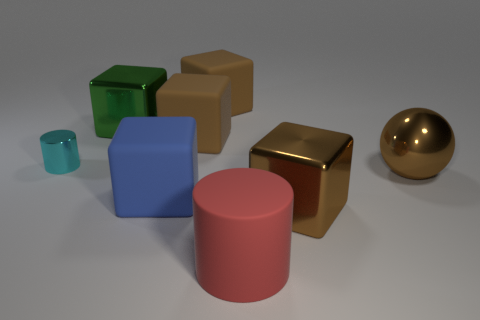Are any tiny green cylinders visible?
Your answer should be very brief. No. How many red matte things are on the left side of the small cylinder that is behind the large block that is on the right side of the red matte thing?
Your answer should be very brief. 0. There is a red matte object; does it have the same shape as the brown rubber object that is in front of the green shiny object?
Your response must be concise. No. Is the number of tiny cyan things greater than the number of large green matte objects?
Your answer should be very brief. Yes. Are there any other things that are the same size as the cyan shiny cylinder?
Offer a very short reply. No. There is a large brown metal thing that is left of the sphere; is its shape the same as the big blue rubber object?
Your response must be concise. Yes. Is the number of big red cylinders to the right of the metal ball greater than the number of brown cubes?
Provide a short and direct response. No. What color is the shiny block behind the large cube that is on the right side of the red matte thing?
Your response must be concise. Green. What number of green metal objects are there?
Ensure brevity in your answer.  1. How many big metal cubes are both behind the blue rubber thing and in front of the cyan cylinder?
Your answer should be very brief. 0. 